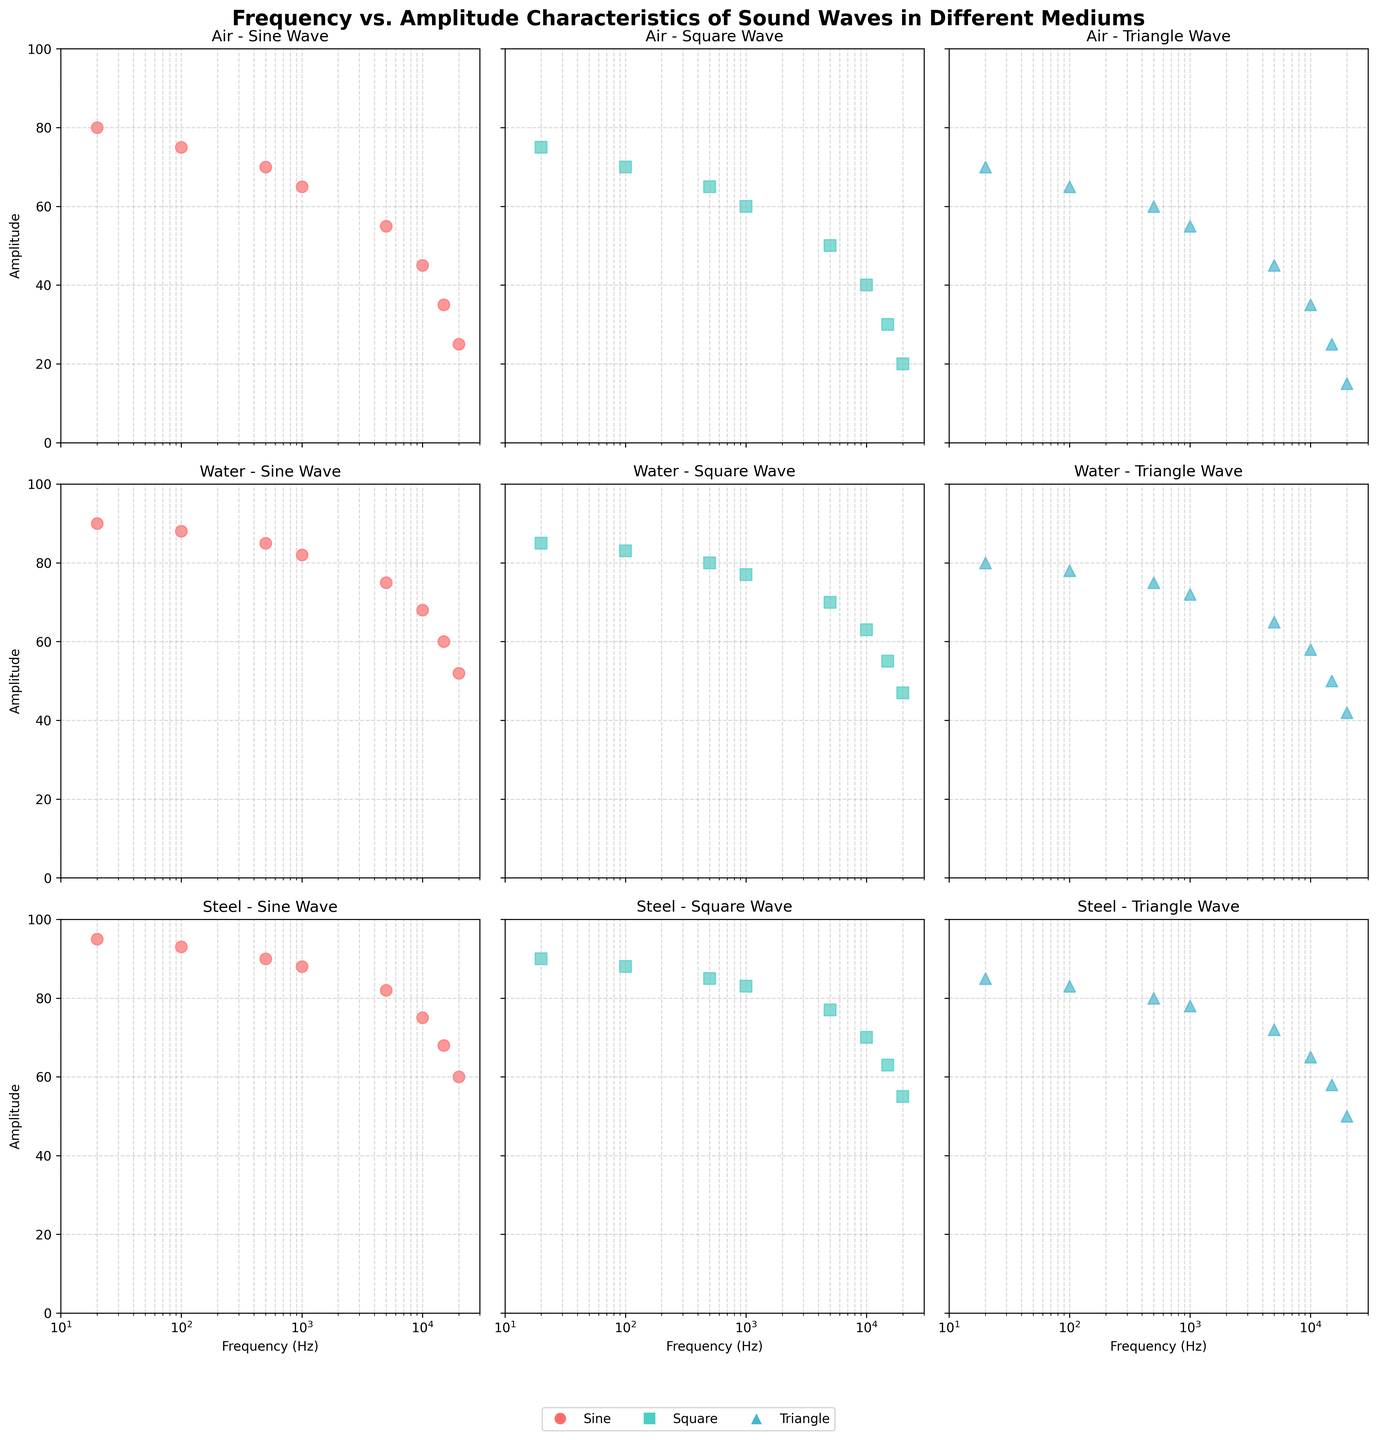What is the overall trend of amplitude with increasing frequency for sine waves in the air? To determine the trend, look at the scatter plot for sine waves in the air. Observe the pattern of data points as frequency increases on the x-axis. The amplitude decreases as the frequency increases.
Answer: Decreasing Which wave type has the highest amplitude at 1000 Hz in the steel medium? Locate the scatter plots for steel medium and find the data points corresponding to 1000 Hz for all wave types. Compare the amplitudes of sine, square, and triangle waves. The sine wave has an amplitude of 88, the square wave 83, and the triangle wave 78.
Answer: Sine wave Is the amplitude of square waves in water always higher than that of sine waves in air at all frequencies? To answer this question, compare the scatter plots of square waves in water and sine waves in the air across all frequencies. Observe the y-values (amplitudes) for each frequency. Yes, at every frequency, the amplitude of the square wave in water is greater than the sine wave in the air.
Answer: Yes What is the difference in amplitude at 20000 Hz between sine and triangle waves in the air medium? Identify the amplitudes at 20000 Hz for sine and triangle waves in the air medium. Sine waves have an amplitude of 25 and triangle waves have 15. Calculate the difference: 25 - 15.
Answer: 10 Which medium shows the least variation in amplitude for sine waves across the frequency range? Compare how the amplitudes of sine waves vary across frequencies in air, water, and steel. Look for the medium where the amplitude values are most consistent (least spread). The steel medium shows the least variation, with amplitude ranging from 95 to 60.
Answer: Steel Between 500 and 10000 Hz, how does the amplitude of square waves change in water? Examine the scatter plot for square waves in water, focusing on frequencies of 500 Hz and 10000 Hz. Note the amplitude values: 500 Hz has 80 and 10000 Hz has 63. The amplitude decreases as frequency increases from 500 to 10000 Hz.
Answer: Decreases Do triangle waves in steel have a higher amplitude than sine waves in water at 15000 Hz? Locate the scatter plots for triangle waves in steel and sine waves in water at 15000 Hz. Compare the amplitudes: triangle waves in steel have 58 and sine waves in water have 60.
Answer: No For the air medium, at which frequency does the sine wave have an amplitude closest to the average amplitude of triangle waves? Calculate the average amplitude of triangle waves in the air: (70 + 65 + 60 + 55 + 45 + 35 + 25 + 15) / 8 = 46.25. Compare this value to the sine wave amplitudes in the air and find the closest one. The sine wave amplitude at 10000 Hz is 45, the closest to 46.25.
Answer: 10000 Hz Which wave type and medium combination shows the steepest decline in amplitude with increasing frequency? Examine the scatter plots for all wave types and mediums. Look for a plot where amplitudes drop sharply as frequency increases. The sine wave in air shows a steep decline from 80 at 20 Hz to 25 at 20000 Hz.
Answer: Sine wave in air 